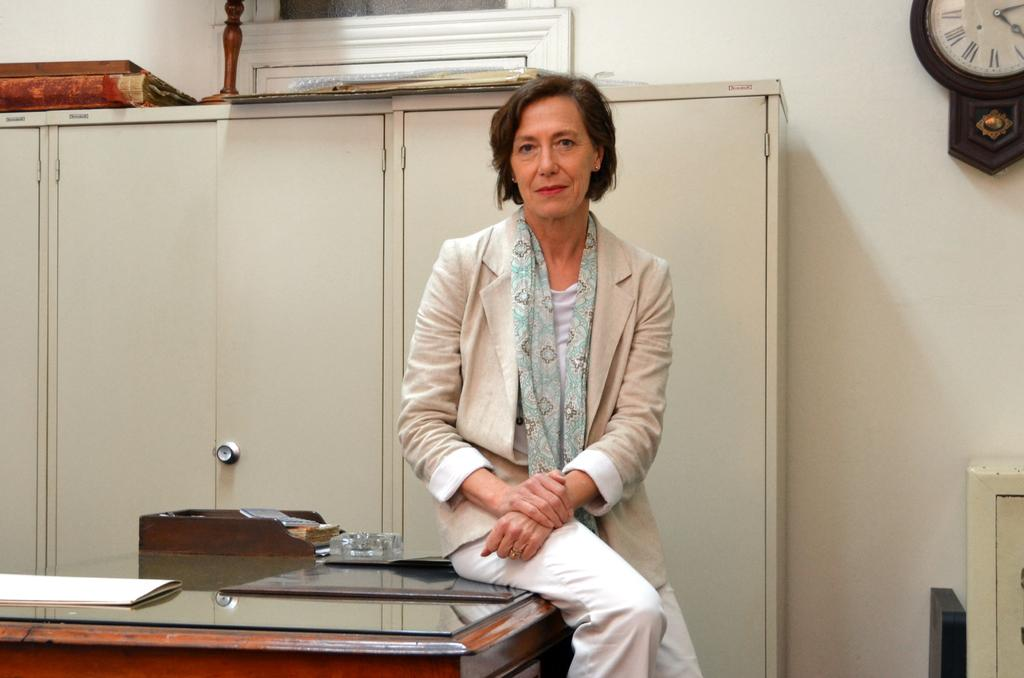What is the woman doing in the image? The woman is sitting on a table in the image. What is the woman wearing? The woman is wearing a coat in the image. What can be seen in the background of the image? There are cupboards and a wall in the background of the image. What time-related object is visible in the image? A clock is observable in the image. Is the woman's daughter sitting next to her in the image? There is no mention of a daughter or another person sitting next to the woman in the image. 